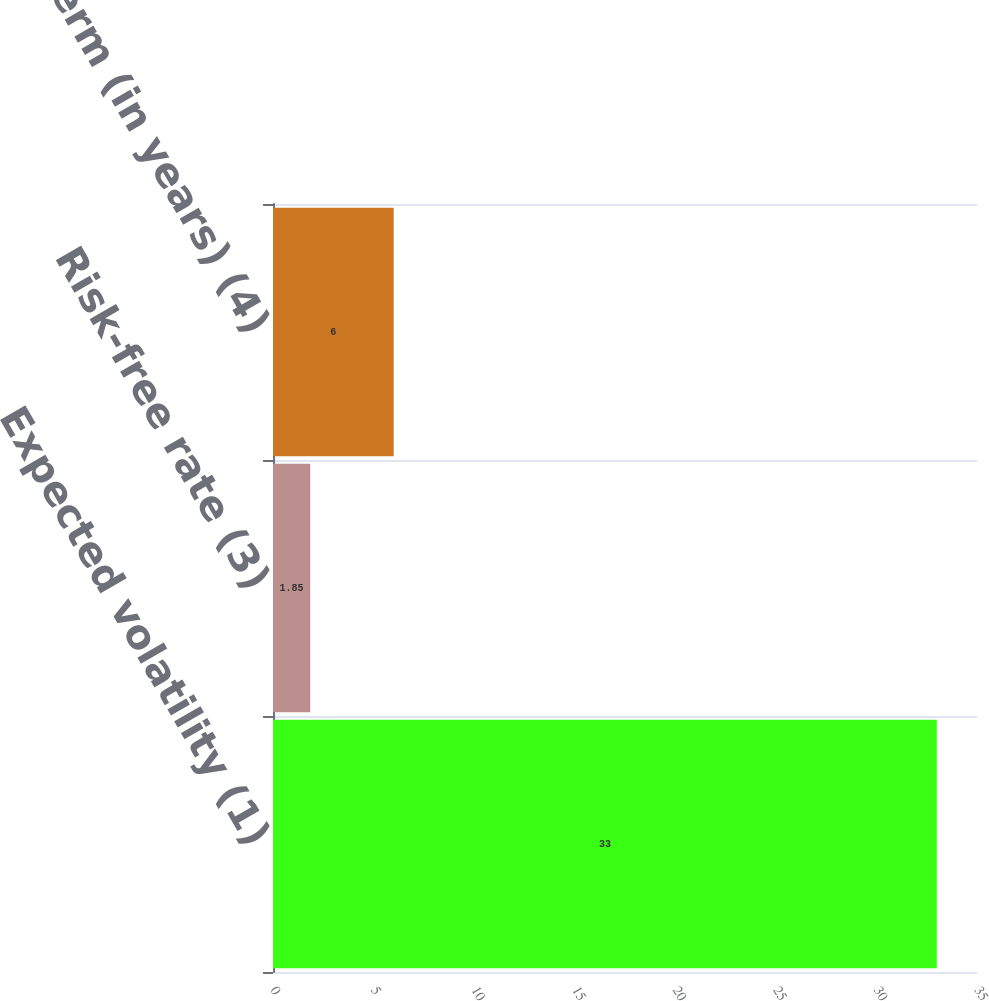<chart> <loc_0><loc_0><loc_500><loc_500><bar_chart><fcel>Expected volatility (1)<fcel>Risk-free rate (3)<fcel>Expected term (in years) (4)<nl><fcel>33<fcel>1.85<fcel>6<nl></chart> 